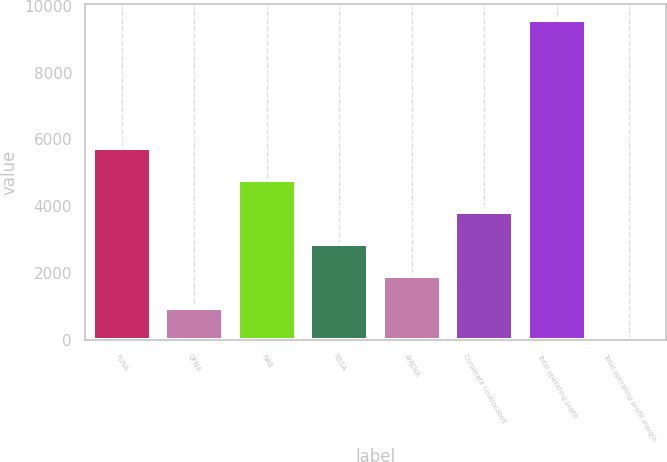<chart> <loc_0><loc_0><loc_500><loc_500><bar_chart><fcel>FLNA<fcel>QFNA<fcel>NAB<fcel>ESSA<fcel>AMENA<fcel>Corporate Unallocated<fcel>Total operating profit<fcel>Total operating profit margin<nl><fcel>5754.36<fcel>971.06<fcel>4797.7<fcel>2884.38<fcel>1927.72<fcel>3841.04<fcel>9581<fcel>14.4<nl></chart> 